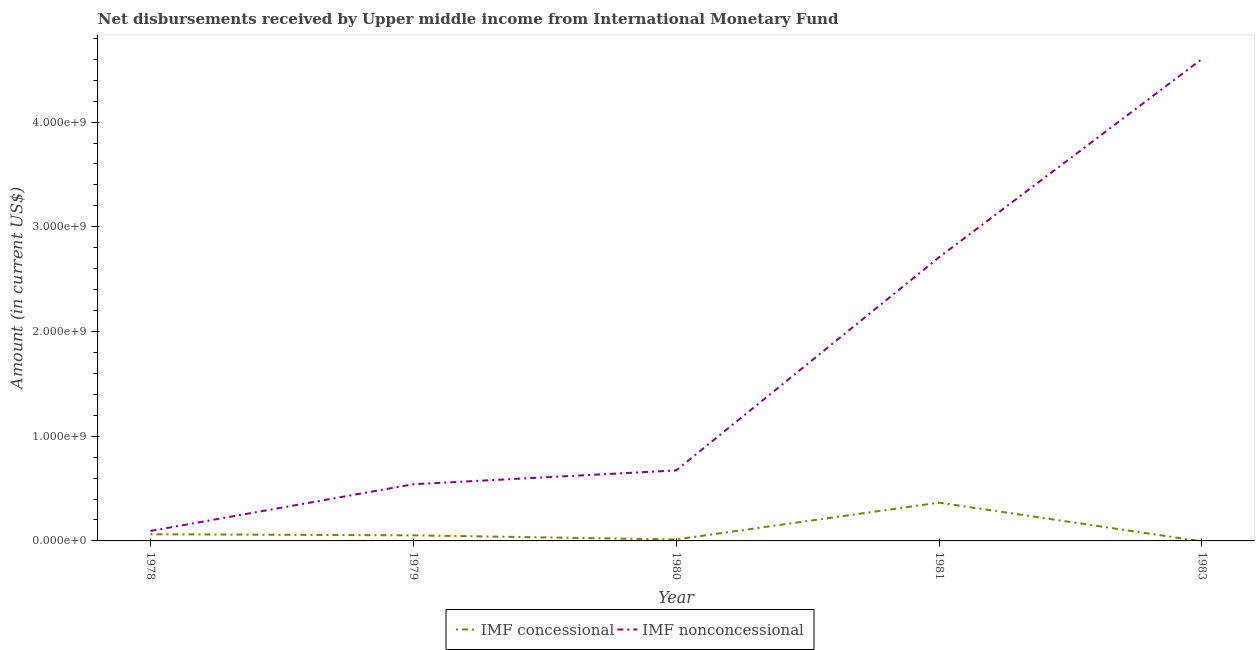Does the line corresponding to net non concessional disbursements from imf intersect with the line corresponding to net concessional disbursements from imf?
Your answer should be compact. No. What is the net non concessional disbursements from imf in 1979?
Give a very brief answer. 5.41e+08. Across all years, what is the maximum net non concessional disbursements from imf?
Keep it short and to the point. 4.60e+09. Across all years, what is the minimum net non concessional disbursements from imf?
Give a very brief answer. 9.52e+07. In which year was the net non concessional disbursements from imf maximum?
Offer a terse response. 1983. What is the total net concessional disbursements from imf in the graph?
Provide a succinct answer. 4.97e+08. What is the difference between the net non concessional disbursements from imf in 1978 and that in 1983?
Your answer should be very brief. -4.51e+09. What is the difference between the net non concessional disbursements from imf in 1979 and the net concessional disbursements from imf in 1978?
Your answer should be very brief. 4.77e+08. What is the average net concessional disbursements from imf per year?
Your response must be concise. 9.94e+07. In the year 1980, what is the difference between the net non concessional disbursements from imf and net concessional disbursements from imf?
Your response must be concise. 6.59e+08. What is the ratio of the net concessional disbursements from imf in 1980 to that in 1981?
Keep it short and to the point. 0.04. Is the net concessional disbursements from imf in 1979 less than that in 1980?
Give a very brief answer. No. What is the difference between the highest and the second highest net non concessional disbursements from imf?
Ensure brevity in your answer.  1.89e+09. What is the difference between the highest and the lowest net concessional disbursements from imf?
Make the answer very short. 3.66e+08. In how many years, is the net non concessional disbursements from imf greater than the average net non concessional disbursements from imf taken over all years?
Keep it short and to the point. 2. Is the net non concessional disbursements from imf strictly greater than the net concessional disbursements from imf over the years?
Provide a short and direct response. Yes. How many years are there in the graph?
Provide a short and direct response. 5. What is the difference between two consecutive major ticks on the Y-axis?
Give a very brief answer. 1.00e+09. Are the values on the major ticks of Y-axis written in scientific E-notation?
Keep it short and to the point. Yes. Where does the legend appear in the graph?
Offer a terse response. Bottom center. How are the legend labels stacked?
Your response must be concise. Horizontal. What is the title of the graph?
Offer a terse response. Net disbursements received by Upper middle income from International Monetary Fund. Does "Number of arrivals" appear as one of the legend labels in the graph?
Make the answer very short. No. What is the label or title of the X-axis?
Offer a terse response. Year. What is the Amount (in current US$) in IMF concessional in 1978?
Your answer should be compact. 6.38e+07. What is the Amount (in current US$) of IMF nonconcessional in 1978?
Provide a short and direct response. 9.52e+07. What is the Amount (in current US$) in IMF concessional in 1979?
Ensure brevity in your answer.  5.32e+07. What is the Amount (in current US$) in IMF nonconcessional in 1979?
Give a very brief answer. 5.41e+08. What is the Amount (in current US$) of IMF concessional in 1980?
Provide a short and direct response. 1.41e+07. What is the Amount (in current US$) of IMF nonconcessional in 1980?
Offer a very short reply. 6.73e+08. What is the Amount (in current US$) of IMF concessional in 1981?
Ensure brevity in your answer.  3.66e+08. What is the Amount (in current US$) in IMF nonconcessional in 1981?
Offer a terse response. 2.71e+09. What is the Amount (in current US$) of IMF concessional in 1983?
Provide a succinct answer. 0. What is the Amount (in current US$) of IMF nonconcessional in 1983?
Provide a short and direct response. 4.60e+09. Across all years, what is the maximum Amount (in current US$) in IMF concessional?
Your response must be concise. 3.66e+08. Across all years, what is the maximum Amount (in current US$) of IMF nonconcessional?
Provide a succinct answer. 4.60e+09. Across all years, what is the minimum Amount (in current US$) of IMF nonconcessional?
Provide a succinct answer. 9.52e+07. What is the total Amount (in current US$) in IMF concessional in the graph?
Keep it short and to the point. 4.97e+08. What is the total Amount (in current US$) in IMF nonconcessional in the graph?
Offer a terse response. 8.62e+09. What is the difference between the Amount (in current US$) of IMF concessional in 1978 and that in 1979?
Your answer should be very brief. 1.05e+07. What is the difference between the Amount (in current US$) in IMF nonconcessional in 1978 and that in 1979?
Give a very brief answer. -4.46e+08. What is the difference between the Amount (in current US$) of IMF concessional in 1978 and that in 1980?
Provide a succinct answer. 4.97e+07. What is the difference between the Amount (in current US$) in IMF nonconcessional in 1978 and that in 1980?
Keep it short and to the point. -5.78e+08. What is the difference between the Amount (in current US$) of IMF concessional in 1978 and that in 1981?
Ensure brevity in your answer.  -3.02e+08. What is the difference between the Amount (in current US$) in IMF nonconcessional in 1978 and that in 1981?
Offer a terse response. -2.61e+09. What is the difference between the Amount (in current US$) of IMF nonconcessional in 1978 and that in 1983?
Your answer should be compact. -4.51e+09. What is the difference between the Amount (in current US$) in IMF concessional in 1979 and that in 1980?
Offer a very short reply. 3.91e+07. What is the difference between the Amount (in current US$) in IMF nonconcessional in 1979 and that in 1980?
Provide a short and direct response. -1.32e+08. What is the difference between the Amount (in current US$) of IMF concessional in 1979 and that in 1981?
Provide a succinct answer. -3.13e+08. What is the difference between the Amount (in current US$) of IMF nonconcessional in 1979 and that in 1981?
Provide a succinct answer. -2.17e+09. What is the difference between the Amount (in current US$) in IMF nonconcessional in 1979 and that in 1983?
Offer a terse response. -4.06e+09. What is the difference between the Amount (in current US$) of IMF concessional in 1980 and that in 1981?
Ensure brevity in your answer.  -3.52e+08. What is the difference between the Amount (in current US$) in IMF nonconcessional in 1980 and that in 1981?
Provide a succinct answer. -2.04e+09. What is the difference between the Amount (in current US$) in IMF nonconcessional in 1980 and that in 1983?
Keep it short and to the point. -3.93e+09. What is the difference between the Amount (in current US$) of IMF nonconcessional in 1981 and that in 1983?
Offer a very short reply. -1.89e+09. What is the difference between the Amount (in current US$) of IMF concessional in 1978 and the Amount (in current US$) of IMF nonconcessional in 1979?
Give a very brief answer. -4.77e+08. What is the difference between the Amount (in current US$) of IMF concessional in 1978 and the Amount (in current US$) of IMF nonconcessional in 1980?
Offer a very short reply. -6.09e+08. What is the difference between the Amount (in current US$) of IMF concessional in 1978 and the Amount (in current US$) of IMF nonconcessional in 1981?
Your answer should be compact. -2.64e+09. What is the difference between the Amount (in current US$) of IMF concessional in 1978 and the Amount (in current US$) of IMF nonconcessional in 1983?
Your response must be concise. -4.54e+09. What is the difference between the Amount (in current US$) of IMF concessional in 1979 and the Amount (in current US$) of IMF nonconcessional in 1980?
Your answer should be compact. -6.20e+08. What is the difference between the Amount (in current US$) of IMF concessional in 1979 and the Amount (in current US$) of IMF nonconcessional in 1981?
Provide a succinct answer. -2.66e+09. What is the difference between the Amount (in current US$) in IMF concessional in 1979 and the Amount (in current US$) in IMF nonconcessional in 1983?
Your answer should be compact. -4.55e+09. What is the difference between the Amount (in current US$) in IMF concessional in 1980 and the Amount (in current US$) in IMF nonconcessional in 1981?
Offer a terse response. -2.69e+09. What is the difference between the Amount (in current US$) in IMF concessional in 1980 and the Amount (in current US$) in IMF nonconcessional in 1983?
Make the answer very short. -4.59e+09. What is the difference between the Amount (in current US$) in IMF concessional in 1981 and the Amount (in current US$) in IMF nonconcessional in 1983?
Your response must be concise. -4.24e+09. What is the average Amount (in current US$) in IMF concessional per year?
Offer a very short reply. 9.94e+07. What is the average Amount (in current US$) in IMF nonconcessional per year?
Provide a short and direct response. 1.72e+09. In the year 1978, what is the difference between the Amount (in current US$) of IMF concessional and Amount (in current US$) of IMF nonconcessional?
Ensure brevity in your answer.  -3.14e+07. In the year 1979, what is the difference between the Amount (in current US$) in IMF concessional and Amount (in current US$) in IMF nonconcessional?
Make the answer very short. -4.88e+08. In the year 1980, what is the difference between the Amount (in current US$) of IMF concessional and Amount (in current US$) of IMF nonconcessional?
Offer a terse response. -6.59e+08. In the year 1981, what is the difference between the Amount (in current US$) of IMF concessional and Amount (in current US$) of IMF nonconcessional?
Provide a succinct answer. -2.34e+09. What is the ratio of the Amount (in current US$) of IMF concessional in 1978 to that in 1979?
Keep it short and to the point. 1.2. What is the ratio of the Amount (in current US$) in IMF nonconcessional in 1978 to that in 1979?
Ensure brevity in your answer.  0.18. What is the ratio of the Amount (in current US$) in IMF concessional in 1978 to that in 1980?
Your answer should be compact. 4.52. What is the ratio of the Amount (in current US$) in IMF nonconcessional in 1978 to that in 1980?
Provide a short and direct response. 0.14. What is the ratio of the Amount (in current US$) in IMF concessional in 1978 to that in 1981?
Offer a very short reply. 0.17. What is the ratio of the Amount (in current US$) in IMF nonconcessional in 1978 to that in 1981?
Offer a terse response. 0.04. What is the ratio of the Amount (in current US$) of IMF nonconcessional in 1978 to that in 1983?
Offer a very short reply. 0.02. What is the ratio of the Amount (in current US$) in IMF concessional in 1979 to that in 1980?
Provide a succinct answer. 3.77. What is the ratio of the Amount (in current US$) in IMF nonconcessional in 1979 to that in 1980?
Offer a very short reply. 0.8. What is the ratio of the Amount (in current US$) in IMF concessional in 1979 to that in 1981?
Your answer should be very brief. 0.15. What is the ratio of the Amount (in current US$) in IMF nonconcessional in 1979 to that in 1981?
Offer a very short reply. 0.2. What is the ratio of the Amount (in current US$) of IMF nonconcessional in 1979 to that in 1983?
Ensure brevity in your answer.  0.12. What is the ratio of the Amount (in current US$) in IMF concessional in 1980 to that in 1981?
Offer a terse response. 0.04. What is the ratio of the Amount (in current US$) of IMF nonconcessional in 1980 to that in 1981?
Offer a very short reply. 0.25. What is the ratio of the Amount (in current US$) in IMF nonconcessional in 1980 to that in 1983?
Provide a succinct answer. 0.15. What is the ratio of the Amount (in current US$) in IMF nonconcessional in 1981 to that in 1983?
Ensure brevity in your answer.  0.59. What is the difference between the highest and the second highest Amount (in current US$) of IMF concessional?
Your answer should be compact. 3.02e+08. What is the difference between the highest and the second highest Amount (in current US$) in IMF nonconcessional?
Provide a short and direct response. 1.89e+09. What is the difference between the highest and the lowest Amount (in current US$) in IMF concessional?
Make the answer very short. 3.66e+08. What is the difference between the highest and the lowest Amount (in current US$) of IMF nonconcessional?
Make the answer very short. 4.51e+09. 